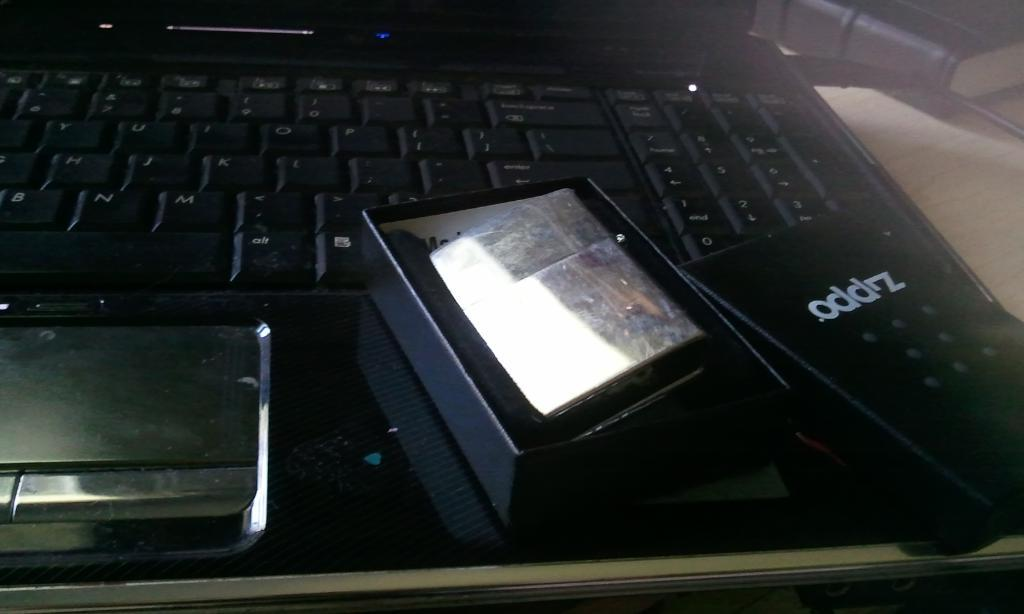<image>
Offer a succinct explanation of the picture presented. A black box that has alighter inside and the box says ODDZ on the lid and the box is sitting on a computer keyboard. 